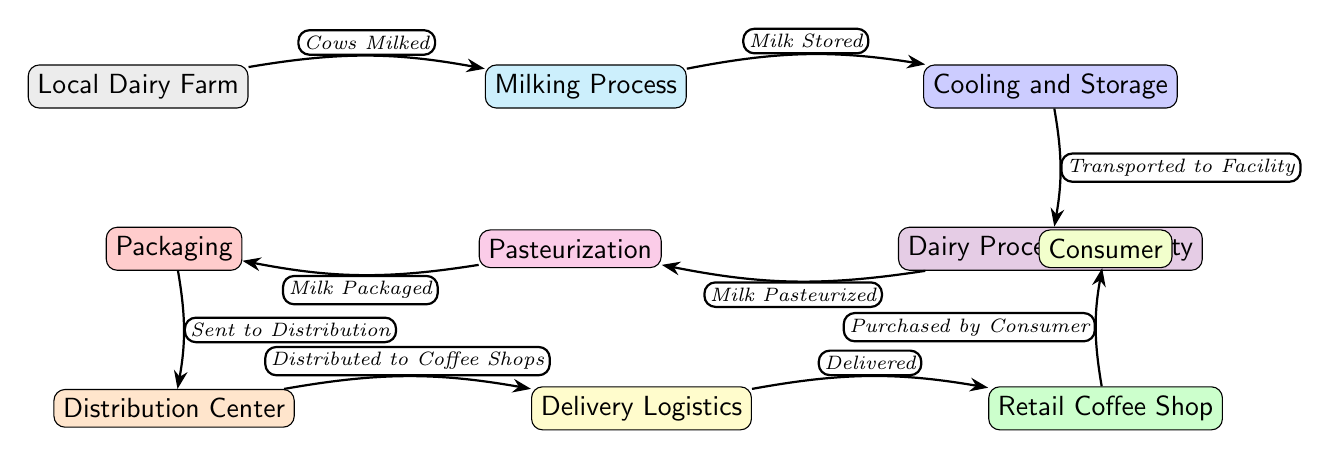What is the first node in the journey of dairy milk? The first node in the journey is Local Dairy Farm, where the dairy farming process begins.
Answer: Local Dairy Farm Which node follows the cooling storage? The node that follows Cooling and Storage is Dairy Processing Facility, indicating the next step in processing the milk.
Answer: Dairy Processing Facility How many nodes are there in total? Counting all the distinct steps in the diagram gives a total of 10 nodes, representing different stages in the milk journey.
Answer: 10 What is the last step in the process? The last step in the process is Consumer, which indicates the final destination of the product after it has passed through all the earlier stages.
Answer: Consumer What is the relationship between the packaging and distribution center? The relationship is represented by the edge labeled "Sent to Distribution," indicating the flow of packaged milk to distribution centers.
Answer: Sent to Distribution How is the milk delivered to retail coffee shops? Milk is delivered to Retail Coffee Shops through Delivery Logistics, as indicated in the flow from the distribution center to the coffee shops.
Answer: Delivery Logistics What stage comes immediately after pasteurization? The stage that comes immediately after Pasteurization is Packaging, which involves preparing the milk for distribution in consumer-friendly units.
Answer: Packaging What process follows the milking process? After the Milking Process, the next step is Cooling and Storage, which is essential for maintaining the quality of milk before further processing.
Answer: Cooling and Storage In what node is pasteurization performed? Pasteurization is performed in the Pasteurization node, specifically emphasized in the diagram as a distinct processing step.
Answer: Pasteurization How is the milk transported from cooling storage? The milk is transported from Cooling and Storage to the Dairy Processing Facility as indicated by the label "Transported to Facility."
Answer: Transported to Facility 